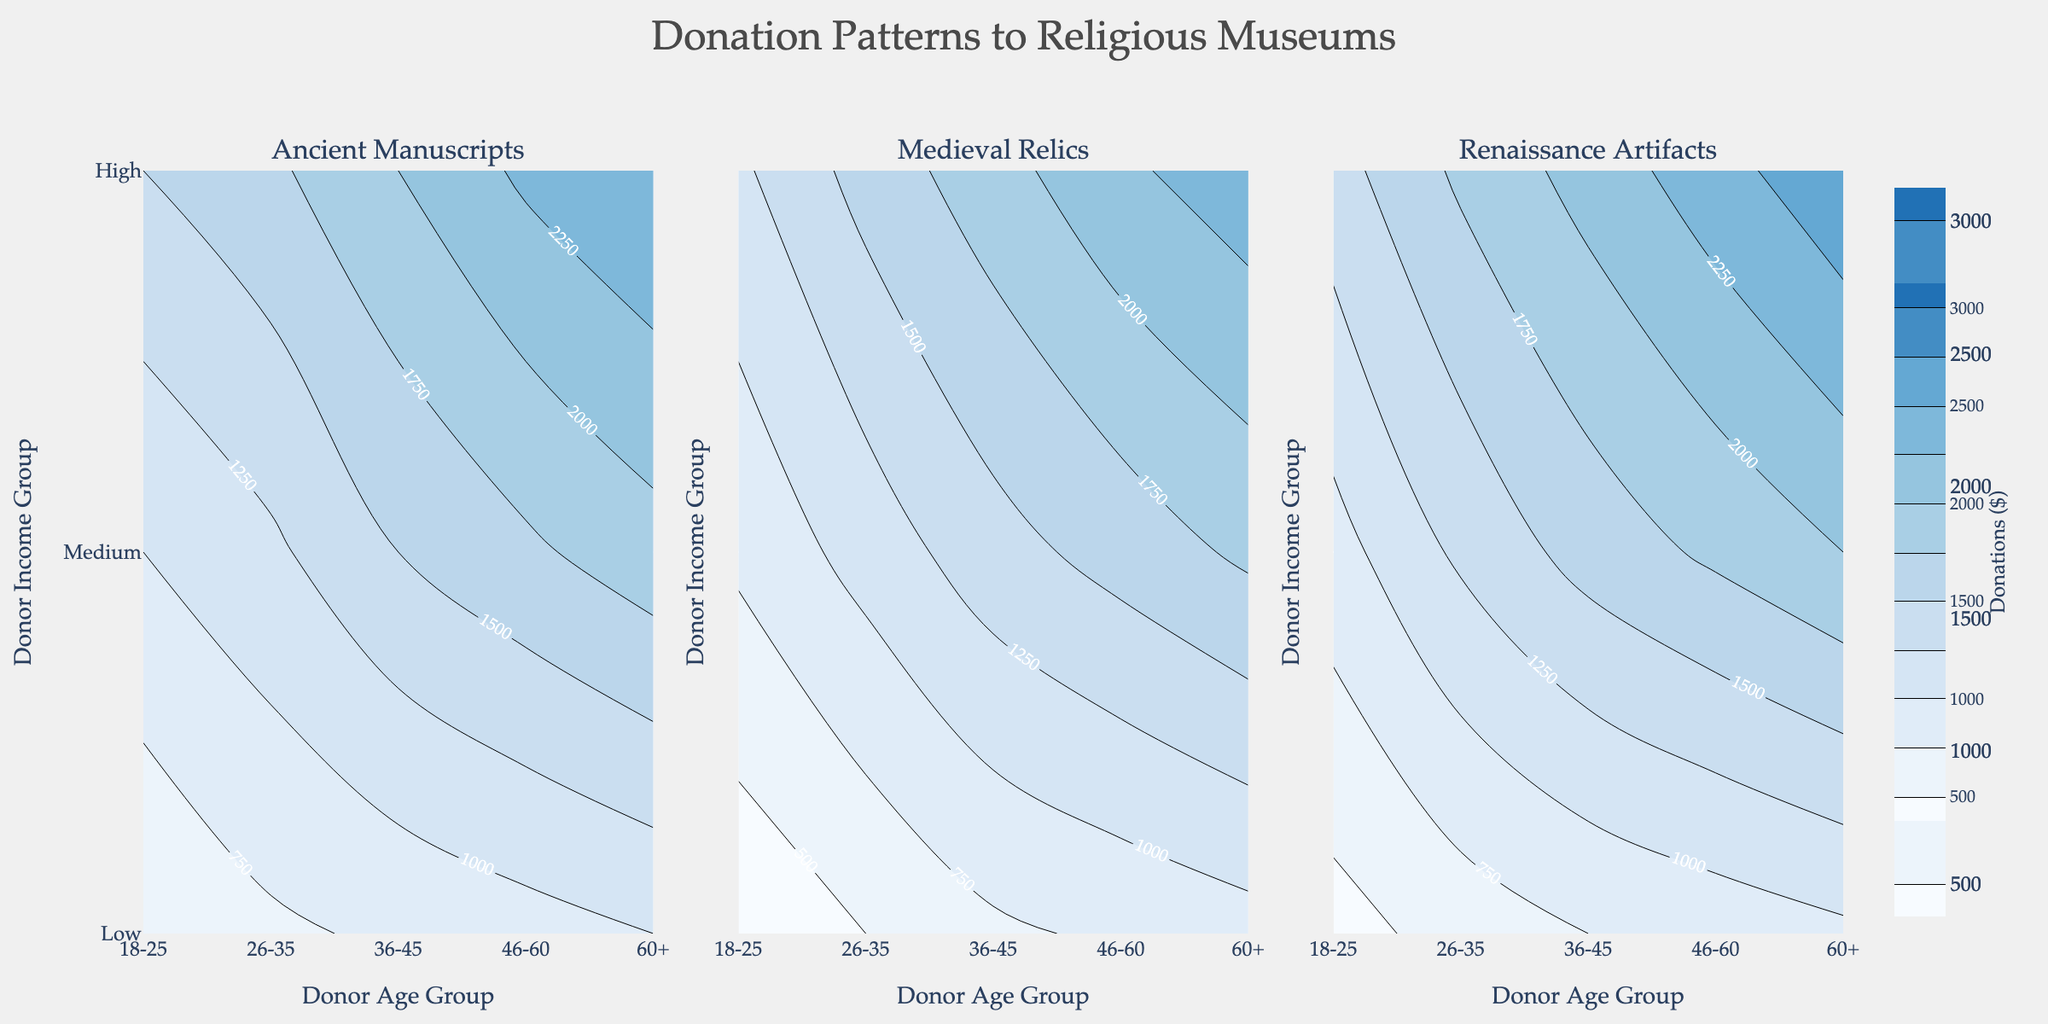What is the highest donation amount for the 'Renaissance Artifacts' exhibit? By looking at the contour plot for the 'Renaissance Artifacts' exhibit type, we can see the darkest region in the top right, indicating the highest donation. This corresponds to the 60+ age group and High-income group.
Answer: $2700 Which exhibit type receives the lowest donations from the 18-25 age group with Low income? By examining the contour plots for all three exhibit types, the lightest shade (indicating the lowest donation) in the corresponding row and column for 18-25 with Low income shows that 'Medieval Relics' has the lowest donation.
Answer: $300 What is the donation range for 'Ancient Manuscripts' across all age groups and income levels? The contour plot for 'Ancient Manuscripts' shows donations ranging from the lightest shades to the darkest shades. The lightest region starts at about $500, and the darkest region peaks around $2500.
Answer: $500-$2500 How do donations to 'Medieval Relics' compare between the 36-45 age group with Medium income and the 46-60 age group with Medium income? By comparing the relevant sections in the Medieval Relics subplot, the donation for the 36-45 age group with Medium income is $1400, while the donation for the 46-60 age group with Medium income is $1600.
Answer: $1400 vs $1600 What trend can be observed regarding donor income levels and their donations to 'Ancient Manuscripts' for the 60+ age group? In the contour plot for 'Ancient Manuscripts,' donations rise as we move from Low to High income levels within the 60+ age group. Donations start around $1000 for Low income, increase to $1900 for Medium income, and peak at $2500 for High income.
Answer: Increasing trend What age group and income level show the highest donation for 'Medieval Relics'? By identifying the darkest contour for the 'Medieval Relics' subplot, we see that the 60+ age group with High income has the highest donation.
Answer: 60+, High income What is the total donation amount for the 26-35 age group across all exhibit types and income levels? Adding the donations from the 26-35 age group across Low, Medium, and High income levels for each exhibit type: (700 + 1200 + 1700) for Ancient Manuscripts, (500 + 1100 + 1600) for Medieval Relics, and (600 + 1300 + 1800) for Renaissance Artifacts. Summing these yields (3600 + 3200 + 3700) = 10500.
Answer: $10500 Which exhibit type has the steepest gradient in donations based on income? By comparing the steepness of color changes in the contour plots, the 'Renaissance Artifacts' exhibit shows the steepest gradient as donations rapidly increase from light to dark with rising income levels.
Answer: Renaissance Artifacts What is the most notable difference in donation patterns between the 'Medieval Relics' and 'Renaissance Artifacts' exhibits? The 'Renaissance Artifacts' exhibit shows a larger increase in donations with rising age and income levels compared to 'Medieval Relics,' which indicates a more gradual increase across the same demographics.
Answer: Rapid vs Gradual What is the average donation amount for the 'Ancient Manuscripts' exhibit for Medium income groups across all age categories? Averaging the Medium income donations for the 'Ancient Manuscripts' exhibit: (1000 + 1200 + 1500 + 1700 + 1900) / 5 = 1460.
Answer: $1460 